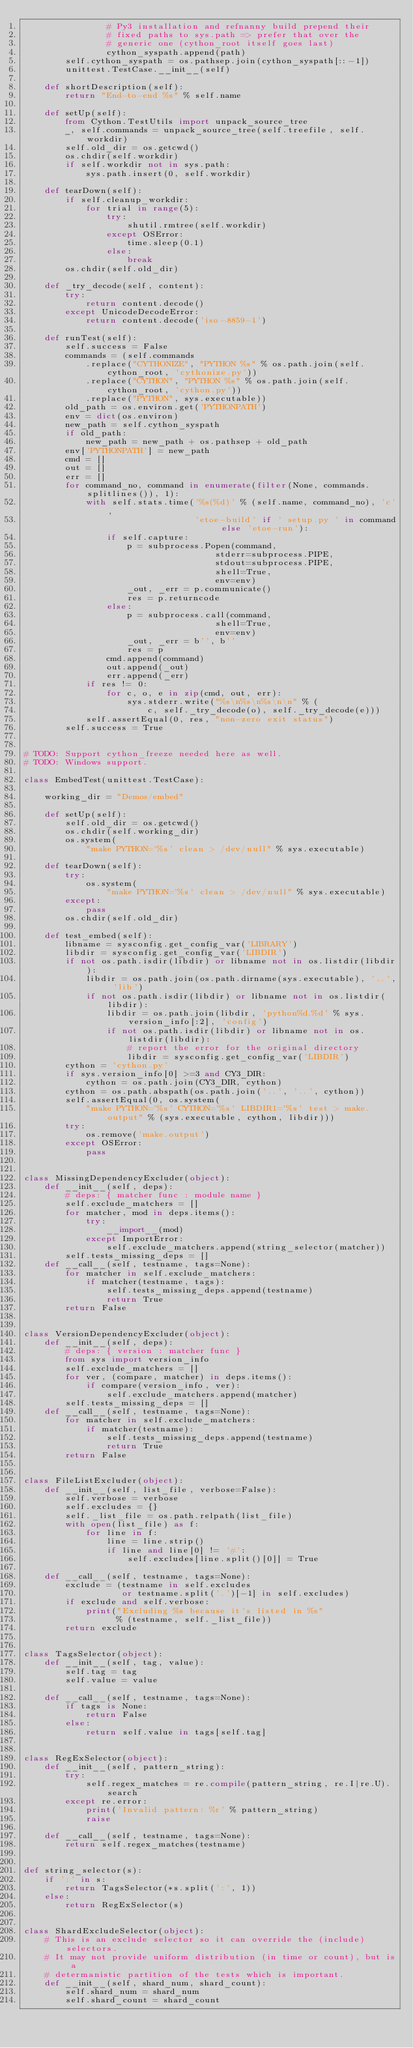Convert code to text. <code><loc_0><loc_0><loc_500><loc_500><_Python_>                # Py3 installation and refnanny build prepend their
                # fixed paths to sys.path => prefer that over the
                # generic one (cython_root itself goes last)
                cython_syspath.append(path)
        self.cython_syspath = os.pathsep.join(cython_syspath[::-1])
        unittest.TestCase.__init__(self)

    def shortDescription(self):
        return "End-to-end %s" % self.name

    def setUp(self):
        from Cython.TestUtils import unpack_source_tree
        _, self.commands = unpack_source_tree(self.treefile, self.workdir)
        self.old_dir = os.getcwd()
        os.chdir(self.workdir)
        if self.workdir not in sys.path:
            sys.path.insert(0, self.workdir)

    def tearDown(self):
        if self.cleanup_workdir:
            for trial in range(5):
                try:
                    shutil.rmtree(self.workdir)
                except OSError:
                    time.sleep(0.1)
                else:
                    break
        os.chdir(self.old_dir)

    def _try_decode(self, content):
        try:
            return content.decode()
        except UnicodeDecodeError:
            return content.decode('iso-8859-1')

    def runTest(self):
        self.success = False
        commands = (self.commands
            .replace("CYTHONIZE", "PYTHON %s" % os.path.join(self.cython_root, 'cythonize.py'))
            .replace("CYTHON", "PYTHON %s" % os.path.join(self.cython_root, 'cython.py'))
            .replace("PYTHON", sys.executable))
        old_path = os.environ.get('PYTHONPATH')
        env = dict(os.environ)
        new_path = self.cython_syspath
        if old_path:
            new_path = new_path + os.pathsep + old_path
        env['PYTHONPATH'] = new_path
        cmd = []
        out = []
        err = []
        for command_no, command in enumerate(filter(None, commands.splitlines()), 1):
            with self.stats.time('%s(%d)' % (self.name, command_no), 'c',
                                 'etoe-build' if ' setup.py ' in command else 'etoe-run'):
                if self.capture:
                    p = subprocess.Popen(command,
                                     stderr=subprocess.PIPE,
                                     stdout=subprocess.PIPE,
                                     shell=True,
                                     env=env)
                    _out, _err = p.communicate()
                    res = p.returncode
                else:
                    p = subprocess.call(command,
                                     shell=True,
                                     env=env)
                    _out, _err = b'', b''
                    res = p
                cmd.append(command)
                out.append(_out)
                err.append(_err)
            if res != 0:
                for c, o, e in zip(cmd, out, err):
                    sys.stderr.write("%s\n%s\n%s\n\n" % (
                        c, self._try_decode(o), self._try_decode(e)))
            self.assertEqual(0, res, "non-zero exit status")
        self.success = True


# TODO: Support cython_freeze needed here as well.
# TODO: Windows support.

class EmbedTest(unittest.TestCase):

    working_dir = "Demos/embed"

    def setUp(self):
        self.old_dir = os.getcwd()
        os.chdir(self.working_dir)
        os.system(
            "make PYTHON='%s' clean > /dev/null" % sys.executable)

    def tearDown(self):
        try:
            os.system(
                "make PYTHON='%s' clean > /dev/null" % sys.executable)
        except:
            pass
        os.chdir(self.old_dir)

    def test_embed(self):
        libname = sysconfig.get_config_var('LIBRARY')
        libdir = sysconfig.get_config_var('LIBDIR')
        if not os.path.isdir(libdir) or libname not in os.listdir(libdir):
            libdir = os.path.join(os.path.dirname(sys.executable), '..', 'lib')
            if not os.path.isdir(libdir) or libname not in os.listdir(libdir):
                libdir = os.path.join(libdir, 'python%d.%d' % sys.version_info[:2], 'config')
                if not os.path.isdir(libdir) or libname not in os.listdir(libdir):
                    # report the error for the original directory
                    libdir = sysconfig.get_config_var('LIBDIR')
        cython = 'cython.py'
        if sys.version_info[0] >=3 and CY3_DIR:
            cython = os.path.join(CY3_DIR, cython)
        cython = os.path.abspath(os.path.join('..', '..', cython))
        self.assertEqual(0, os.system(
            "make PYTHON='%s' CYTHON='%s' LIBDIR1='%s' test > make.output" % (sys.executable, cython, libdir)))
        try:
            os.remove('make.output')
        except OSError:
            pass


class MissingDependencyExcluder(object):
    def __init__(self, deps):
        # deps: { matcher func : module name }
        self.exclude_matchers = []
        for matcher, mod in deps.items():
            try:
                __import__(mod)
            except ImportError:
                self.exclude_matchers.append(string_selector(matcher))
        self.tests_missing_deps = []
    def __call__(self, testname, tags=None):
        for matcher in self.exclude_matchers:
            if matcher(testname, tags):
                self.tests_missing_deps.append(testname)
                return True
        return False


class VersionDependencyExcluder(object):
    def __init__(self, deps):
        # deps: { version : matcher func }
        from sys import version_info
        self.exclude_matchers = []
        for ver, (compare, matcher) in deps.items():
            if compare(version_info, ver):
                self.exclude_matchers.append(matcher)
        self.tests_missing_deps = []
    def __call__(self, testname, tags=None):
        for matcher in self.exclude_matchers:
            if matcher(testname):
                self.tests_missing_deps.append(testname)
                return True
        return False


class FileListExcluder(object):
    def __init__(self, list_file, verbose=False):
        self.verbose = verbose
        self.excludes = {}
        self._list_file = os.path.relpath(list_file)
        with open(list_file) as f:
            for line in f:
                line = line.strip()
                if line and line[0] != '#':
                    self.excludes[line.split()[0]] = True

    def __call__(self, testname, tags=None):
        exclude = (testname in self.excludes
                   or testname.split('.')[-1] in self.excludes)
        if exclude and self.verbose:
            print("Excluding %s because it's listed in %s"
                  % (testname, self._list_file))
        return exclude


class TagsSelector(object):
    def __init__(self, tag, value):
        self.tag = tag
        self.value = value

    def __call__(self, testname, tags=None):
        if tags is None:
            return False
        else:
            return self.value in tags[self.tag]


class RegExSelector(object):
    def __init__(self, pattern_string):
        try:
            self.regex_matches = re.compile(pattern_string, re.I|re.U).search
        except re.error:
            print('Invalid pattern: %r' % pattern_string)
            raise

    def __call__(self, testname, tags=None):
        return self.regex_matches(testname)


def string_selector(s):
    if ':' in s:
        return TagsSelector(*s.split(':', 1))
    else:
        return RegExSelector(s)


class ShardExcludeSelector(object):
    # This is an exclude selector so it can override the (include) selectors.
    # It may not provide uniform distribution (in time or count), but is a
    # determanistic partition of the tests which is important.
    def __init__(self, shard_num, shard_count):
        self.shard_num = shard_num
        self.shard_count = shard_count
</code> 